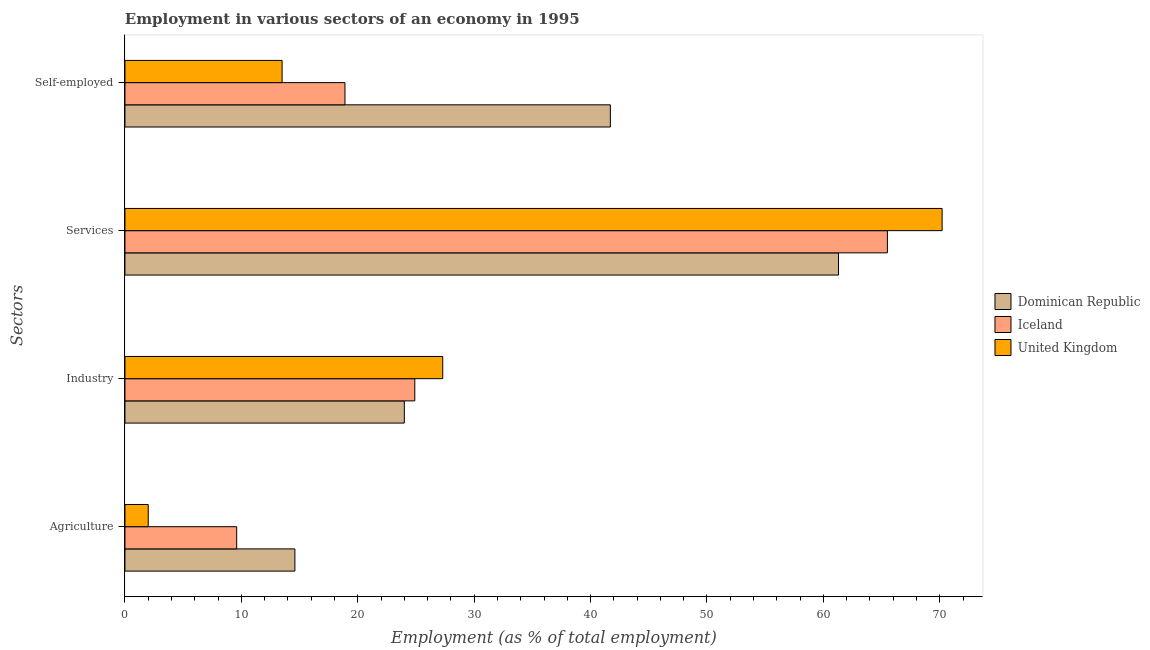How many different coloured bars are there?
Offer a very short reply. 3. How many groups of bars are there?
Make the answer very short. 4. How many bars are there on the 4th tick from the top?
Keep it short and to the point. 3. What is the label of the 4th group of bars from the top?
Ensure brevity in your answer.  Agriculture. Across all countries, what is the maximum percentage of workers in agriculture?
Make the answer very short. 14.6. Across all countries, what is the minimum percentage of workers in services?
Keep it short and to the point. 61.3. In which country was the percentage of workers in industry maximum?
Keep it short and to the point. United Kingdom. In which country was the percentage of workers in industry minimum?
Offer a terse response. Dominican Republic. What is the total percentage of self employed workers in the graph?
Make the answer very short. 74.1. What is the difference between the percentage of workers in industry in Iceland and that in Dominican Republic?
Give a very brief answer. 0.9. What is the difference between the percentage of workers in industry in Dominican Republic and the percentage of workers in services in Iceland?
Make the answer very short. -41.5. What is the average percentage of workers in agriculture per country?
Offer a terse response. 8.73. What is the difference between the percentage of workers in industry and percentage of workers in services in Iceland?
Ensure brevity in your answer.  -40.6. What is the ratio of the percentage of workers in agriculture in Dominican Republic to that in United Kingdom?
Offer a very short reply. 7.3. Is the percentage of workers in industry in Iceland less than that in United Kingdom?
Provide a succinct answer. Yes. What is the difference between the highest and the second highest percentage of workers in services?
Keep it short and to the point. 4.7. What is the difference between the highest and the lowest percentage of self employed workers?
Your response must be concise. 28.2. In how many countries, is the percentage of workers in services greater than the average percentage of workers in services taken over all countries?
Offer a terse response. 1. Is it the case that in every country, the sum of the percentage of workers in services and percentage of workers in industry is greater than the sum of percentage of workers in agriculture and percentage of self employed workers?
Provide a succinct answer. Yes. What does the 1st bar from the top in Industry represents?
Ensure brevity in your answer.  United Kingdom. How many bars are there?
Offer a very short reply. 12. Are all the bars in the graph horizontal?
Offer a terse response. Yes. What is the difference between two consecutive major ticks on the X-axis?
Provide a succinct answer. 10. Does the graph contain grids?
Your answer should be compact. No. How many legend labels are there?
Give a very brief answer. 3. What is the title of the graph?
Provide a short and direct response. Employment in various sectors of an economy in 1995. What is the label or title of the X-axis?
Provide a succinct answer. Employment (as % of total employment). What is the label or title of the Y-axis?
Keep it short and to the point. Sectors. What is the Employment (as % of total employment) of Dominican Republic in Agriculture?
Give a very brief answer. 14.6. What is the Employment (as % of total employment) of Iceland in Agriculture?
Provide a short and direct response. 9.6. What is the Employment (as % of total employment) in Iceland in Industry?
Your answer should be compact. 24.9. What is the Employment (as % of total employment) in United Kingdom in Industry?
Ensure brevity in your answer.  27.3. What is the Employment (as % of total employment) in Dominican Republic in Services?
Ensure brevity in your answer.  61.3. What is the Employment (as % of total employment) of Iceland in Services?
Ensure brevity in your answer.  65.5. What is the Employment (as % of total employment) in United Kingdom in Services?
Your answer should be very brief. 70.2. What is the Employment (as % of total employment) in Dominican Republic in Self-employed?
Your answer should be very brief. 41.7. What is the Employment (as % of total employment) in Iceland in Self-employed?
Your answer should be compact. 18.9. What is the Employment (as % of total employment) of United Kingdom in Self-employed?
Your answer should be very brief. 13.5. Across all Sectors, what is the maximum Employment (as % of total employment) in Dominican Republic?
Your answer should be compact. 61.3. Across all Sectors, what is the maximum Employment (as % of total employment) of Iceland?
Make the answer very short. 65.5. Across all Sectors, what is the maximum Employment (as % of total employment) in United Kingdom?
Offer a very short reply. 70.2. Across all Sectors, what is the minimum Employment (as % of total employment) in Dominican Republic?
Give a very brief answer. 14.6. Across all Sectors, what is the minimum Employment (as % of total employment) in Iceland?
Your answer should be compact. 9.6. What is the total Employment (as % of total employment) of Dominican Republic in the graph?
Provide a succinct answer. 141.6. What is the total Employment (as % of total employment) in Iceland in the graph?
Give a very brief answer. 118.9. What is the total Employment (as % of total employment) of United Kingdom in the graph?
Ensure brevity in your answer.  113. What is the difference between the Employment (as % of total employment) of Dominican Republic in Agriculture and that in Industry?
Your answer should be very brief. -9.4. What is the difference between the Employment (as % of total employment) in Iceland in Agriculture and that in Industry?
Provide a succinct answer. -15.3. What is the difference between the Employment (as % of total employment) of United Kingdom in Agriculture and that in Industry?
Provide a short and direct response. -25.3. What is the difference between the Employment (as % of total employment) in Dominican Republic in Agriculture and that in Services?
Offer a terse response. -46.7. What is the difference between the Employment (as % of total employment) of Iceland in Agriculture and that in Services?
Offer a terse response. -55.9. What is the difference between the Employment (as % of total employment) of United Kingdom in Agriculture and that in Services?
Provide a short and direct response. -68.2. What is the difference between the Employment (as % of total employment) in Dominican Republic in Agriculture and that in Self-employed?
Keep it short and to the point. -27.1. What is the difference between the Employment (as % of total employment) in United Kingdom in Agriculture and that in Self-employed?
Keep it short and to the point. -11.5. What is the difference between the Employment (as % of total employment) in Dominican Republic in Industry and that in Services?
Your answer should be very brief. -37.3. What is the difference between the Employment (as % of total employment) in Iceland in Industry and that in Services?
Your answer should be compact. -40.6. What is the difference between the Employment (as % of total employment) in United Kingdom in Industry and that in Services?
Ensure brevity in your answer.  -42.9. What is the difference between the Employment (as % of total employment) of Dominican Republic in Industry and that in Self-employed?
Offer a very short reply. -17.7. What is the difference between the Employment (as % of total employment) in Iceland in Industry and that in Self-employed?
Ensure brevity in your answer.  6. What is the difference between the Employment (as % of total employment) in Dominican Republic in Services and that in Self-employed?
Your response must be concise. 19.6. What is the difference between the Employment (as % of total employment) of Iceland in Services and that in Self-employed?
Provide a succinct answer. 46.6. What is the difference between the Employment (as % of total employment) in United Kingdom in Services and that in Self-employed?
Give a very brief answer. 56.7. What is the difference between the Employment (as % of total employment) of Dominican Republic in Agriculture and the Employment (as % of total employment) of Iceland in Industry?
Offer a very short reply. -10.3. What is the difference between the Employment (as % of total employment) of Dominican Republic in Agriculture and the Employment (as % of total employment) of United Kingdom in Industry?
Keep it short and to the point. -12.7. What is the difference between the Employment (as % of total employment) in Iceland in Agriculture and the Employment (as % of total employment) in United Kingdom in Industry?
Ensure brevity in your answer.  -17.7. What is the difference between the Employment (as % of total employment) of Dominican Republic in Agriculture and the Employment (as % of total employment) of Iceland in Services?
Your response must be concise. -50.9. What is the difference between the Employment (as % of total employment) of Dominican Republic in Agriculture and the Employment (as % of total employment) of United Kingdom in Services?
Your answer should be compact. -55.6. What is the difference between the Employment (as % of total employment) of Iceland in Agriculture and the Employment (as % of total employment) of United Kingdom in Services?
Make the answer very short. -60.6. What is the difference between the Employment (as % of total employment) in Dominican Republic in Agriculture and the Employment (as % of total employment) in Iceland in Self-employed?
Offer a terse response. -4.3. What is the difference between the Employment (as % of total employment) in Dominican Republic in Agriculture and the Employment (as % of total employment) in United Kingdom in Self-employed?
Give a very brief answer. 1.1. What is the difference between the Employment (as % of total employment) in Iceland in Agriculture and the Employment (as % of total employment) in United Kingdom in Self-employed?
Provide a short and direct response. -3.9. What is the difference between the Employment (as % of total employment) of Dominican Republic in Industry and the Employment (as % of total employment) of Iceland in Services?
Keep it short and to the point. -41.5. What is the difference between the Employment (as % of total employment) in Dominican Republic in Industry and the Employment (as % of total employment) in United Kingdom in Services?
Offer a terse response. -46.2. What is the difference between the Employment (as % of total employment) of Iceland in Industry and the Employment (as % of total employment) of United Kingdom in Services?
Your answer should be compact. -45.3. What is the difference between the Employment (as % of total employment) in Dominican Republic in Industry and the Employment (as % of total employment) in Iceland in Self-employed?
Your response must be concise. 5.1. What is the difference between the Employment (as % of total employment) in Dominican Republic in Services and the Employment (as % of total employment) in Iceland in Self-employed?
Your answer should be very brief. 42.4. What is the difference between the Employment (as % of total employment) in Dominican Republic in Services and the Employment (as % of total employment) in United Kingdom in Self-employed?
Give a very brief answer. 47.8. What is the difference between the Employment (as % of total employment) in Iceland in Services and the Employment (as % of total employment) in United Kingdom in Self-employed?
Provide a succinct answer. 52. What is the average Employment (as % of total employment) in Dominican Republic per Sectors?
Offer a very short reply. 35.4. What is the average Employment (as % of total employment) in Iceland per Sectors?
Offer a very short reply. 29.73. What is the average Employment (as % of total employment) of United Kingdom per Sectors?
Your response must be concise. 28.25. What is the difference between the Employment (as % of total employment) in Dominican Republic and Employment (as % of total employment) in United Kingdom in Agriculture?
Provide a short and direct response. 12.6. What is the difference between the Employment (as % of total employment) of Iceland and Employment (as % of total employment) of United Kingdom in Agriculture?
Keep it short and to the point. 7.6. What is the difference between the Employment (as % of total employment) in Dominican Republic and Employment (as % of total employment) in Iceland in Industry?
Offer a terse response. -0.9. What is the difference between the Employment (as % of total employment) of Dominican Republic and Employment (as % of total employment) of United Kingdom in Industry?
Keep it short and to the point. -3.3. What is the difference between the Employment (as % of total employment) in Iceland and Employment (as % of total employment) in United Kingdom in Industry?
Your answer should be compact. -2.4. What is the difference between the Employment (as % of total employment) of Dominican Republic and Employment (as % of total employment) of Iceland in Services?
Make the answer very short. -4.2. What is the difference between the Employment (as % of total employment) of Iceland and Employment (as % of total employment) of United Kingdom in Services?
Provide a succinct answer. -4.7. What is the difference between the Employment (as % of total employment) in Dominican Republic and Employment (as % of total employment) in Iceland in Self-employed?
Provide a succinct answer. 22.8. What is the difference between the Employment (as % of total employment) in Dominican Republic and Employment (as % of total employment) in United Kingdom in Self-employed?
Offer a terse response. 28.2. What is the ratio of the Employment (as % of total employment) of Dominican Republic in Agriculture to that in Industry?
Ensure brevity in your answer.  0.61. What is the ratio of the Employment (as % of total employment) in Iceland in Agriculture to that in Industry?
Give a very brief answer. 0.39. What is the ratio of the Employment (as % of total employment) in United Kingdom in Agriculture to that in Industry?
Offer a very short reply. 0.07. What is the ratio of the Employment (as % of total employment) of Dominican Republic in Agriculture to that in Services?
Provide a succinct answer. 0.24. What is the ratio of the Employment (as % of total employment) of Iceland in Agriculture to that in Services?
Offer a terse response. 0.15. What is the ratio of the Employment (as % of total employment) of United Kingdom in Agriculture to that in Services?
Give a very brief answer. 0.03. What is the ratio of the Employment (as % of total employment) of Dominican Republic in Agriculture to that in Self-employed?
Provide a short and direct response. 0.35. What is the ratio of the Employment (as % of total employment) in Iceland in Agriculture to that in Self-employed?
Make the answer very short. 0.51. What is the ratio of the Employment (as % of total employment) in United Kingdom in Agriculture to that in Self-employed?
Your response must be concise. 0.15. What is the ratio of the Employment (as % of total employment) in Dominican Republic in Industry to that in Services?
Ensure brevity in your answer.  0.39. What is the ratio of the Employment (as % of total employment) in Iceland in Industry to that in Services?
Your response must be concise. 0.38. What is the ratio of the Employment (as % of total employment) of United Kingdom in Industry to that in Services?
Provide a succinct answer. 0.39. What is the ratio of the Employment (as % of total employment) in Dominican Republic in Industry to that in Self-employed?
Your response must be concise. 0.58. What is the ratio of the Employment (as % of total employment) in Iceland in Industry to that in Self-employed?
Ensure brevity in your answer.  1.32. What is the ratio of the Employment (as % of total employment) in United Kingdom in Industry to that in Self-employed?
Ensure brevity in your answer.  2.02. What is the ratio of the Employment (as % of total employment) in Dominican Republic in Services to that in Self-employed?
Offer a terse response. 1.47. What is the ratio of the Employment (as % of total employment) of Iceland in Services to that in Self-employed?
Ensure brevity in your answer.  3.47. What is the ratio of the Employment (as % of total employment) in United Kingdom in Services to that in Self-employed?
Make the answer very short. 5.2. What is the difference between the highest and the second highest Employment (as % of total employment) in Dominican Republic?
Make the answer very short. 19.6. What is the difference between the highest and the second highest Employment (as % of total employment) of Iceland?
Your answer should be very brief. 40.6. What is the difference between the highest and the second highest Employment (as % of total employment) of United Kingdom?
Your answer should be very brief. 42.9. What is the difference between the highest and the lowest Employment (as % of total employment) of Dominican Republic?
Offer a terse response. 46.7. What is the difference between the highest and the lowest Employment (as % of total employment) of Iceland?
Provide a short and direct response. 55.9. What is the difference between the highest and the lowest Employment (as % of total employment) of United Kingdom?
Ensure brevity in your answer.  68.2. 